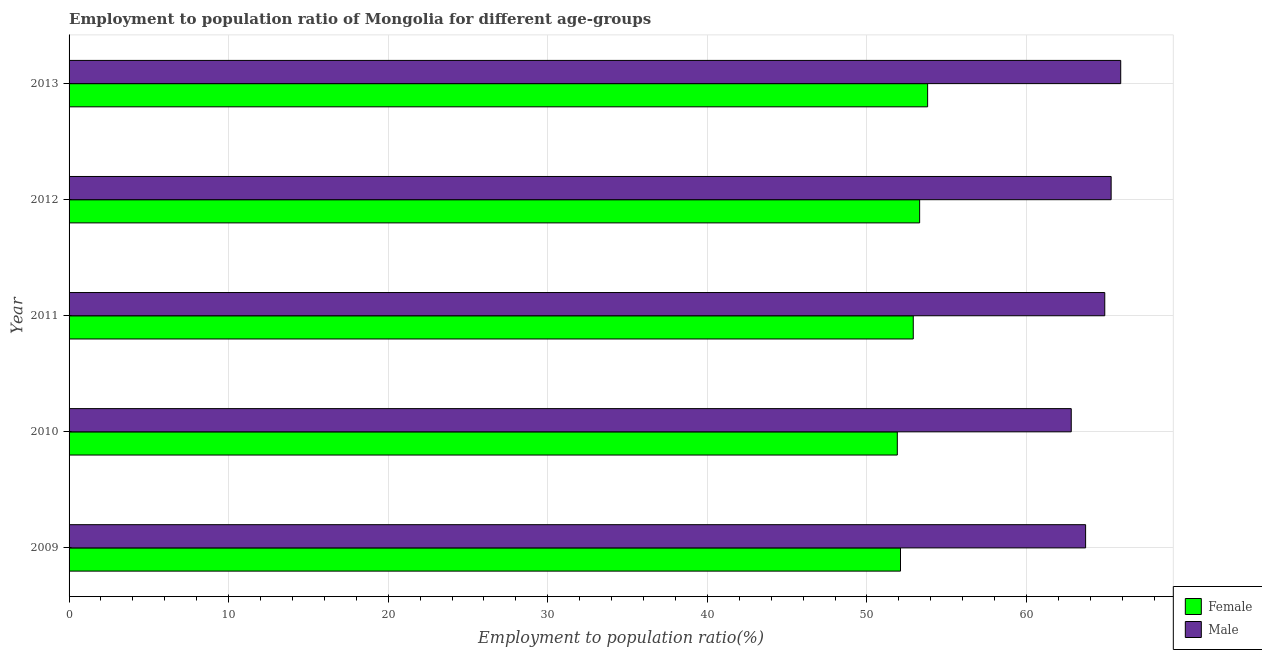Are the number of bars per tick equal to the number of legend labels?
Your answer should be compact. Yes. Are the number of bars on each tick of the Y-axis equal?
Your answer should be compact. Yes. What is the label of the 5th group of bars from the top?
Ensure brevity in your answer.  2009. In how many cases, is the number of bars for a given year not equal to the number of legend labels?
Make the answer very short. 0. What is the employment to population ratio(male) in 2011?
Keep it short and to the point. 64.9. Across all years, what is the maximum employment to population ratio(male)?
Offer a terse response. 65.9. Across all years, what is the minimum employment to population ratio(female)?
Provide a short and direct response. 51.9. What is the total employment to population ratio(male) in the graph?
Keep it short and to the point. 322.6. What is the difference between the employment to population ratio(female) in 2009 and that in 2012?
Your answer should be very brief. -1.2. What is the difference between the employment to population ratio(male) in 2010 and the employment to population ratio(female) in 2013?
Provide a succinct answer. 9. What is the average employment to population ratio(male) per year?
Offer a very short reply. 64.52. In the year 2009, what is the difference between the employment to population ratio(male) and employment to population ratio(female)?
Offer a terse response. 11.6. In how many years, is the employment to population ratio(male) greater than 36 %?
Give a very brief answer. 5. Is the difference between the employment to population ratio(male) in 2010 and 2011 greater than the difference between the employment to population ratio(female) in 2010 and 2011?
Your response must be concise. No. What is the difference between the highest and the second highest employment to population ratio(male)?
Make the answer very short. 0.6. What is the difference between the highest and the lowest employment to population ratio(female)?
Your response must be concise. 1.9. In how many years, is the employment to population ratio(male) greater than the average employment to population ratio(male) taken over all years?
Provide a short and direct response. 3. Is the sum of the employment to population ratio(male) in 2010 and 2013 greater than the maximum employment to population ratio(female) across all years?
Your answer should be very brief. Yes. What does the 1st bar from the top in 2010 represents?
Give a very brief answer. Male. What does the 2nd bar from the bottom in 2010 represents?
Your answer should be very brief. Male. How many bars are there?
Provide a short and direct response. 10. How many years are there in the graph?
Offer a terse response. 5. What is the difference between two consecutive major ticks on the X-axis?
Offer a very short reply. 10. Are the values on the major ticks of X-axis written in scientific E-notation?
Provide a short and direct response. No. Does the graph contain any zero values?
Ensure brevity in your answer.  No. Where does the legend appear in the graph?
Give a very brief answer. Bottom right. What is the title of the graph?
Offer a terse response. Employment to population ratio of Mongolia for different age-groups. What is the label or title of the X-axis?
Ensure brevity in your answer.  Employment to population ratio(%). What is the label or title of the Y-axis?
Make the answer very short. Year. What is the Employment to population ratio(%) of Female in 2009?
Offer a terse response. 52.1. What is the Employment to population ratio(%) in Male in 2009?
Offer a very short reply. 63.7. What is the Employment to population ratio(%) in Female in 2010?
Provide a succinct answer. 51.9. What is the Employment to population ratio(%) of Male in 2010?
Your answer should be very brief. 62.8. What is the Employment to population ratio(%) in Female in 2011?
Keep it short and to the point. 52.9. What is the Employment to population ratio(%) of Male in 2011?
Offer a very short reply. 64.9. What is the Employment to population ratio(%) of Female in 2012?
Give a very brief answer. 53.3. What is the Employment to population ratio(%) of Male in 2012?
Keep it short and to the point. 65.3. What is the Employment to population ratio(%) in Female in 2013?
Make the answer very short. 53.8. What is the Employment to population ratio(%) in Male in 2013?
Your answer should be compact. 65.9. Across all years, what is the maximum Employment to population ratio(%) in Female?
Make the answer very short. 53.8. Across all years, what is the maximum Employment to population ratio(%) of Male?
Your answer should be very brief. 65.9. Across all years, what is the minimum Employment to population ratio(%) in Female?
Offer a very short reply. 51.9. Across all years, what is the minimum Employment to population ratio(%) in Male?
Your answer should be compact. 62.8. What is the total Employment to population ratio(%) of Female in the graph?
Ensure brevity in your answer.  264. What is the total Employment to population ratio(%) in Male in the graph?
Offer a very short reply. 322.6. What is the difference between the Employment to population ratio(%) in Male in 2009 and that in 2010?
Keep it short and to the point. 0.9. What is the difference between the Employment to population ratio(%) in Female in 2009 and that in 2012?
Your response must be concise. -1.2. What is the difference between the Employment to population ratio(%) of Male in 2009 and that in 2012?
Provide a succinct answer. -1.6. What is the difference between the Employment to population ratio(%) in Female in 2010 and that in 2011?
Ensure brevity in your answer.  -1. What is the difference between the Employment to population ratio(%) in Male in 2010 and that in 2012?
Provide a succinct answer. -2.5. What is the difference between the Employment to population ratio(%) in Female in 2011 and that in 2012?
Your answer should be very brief. -0.4. What is the difference between the Employment to population ratio(%) of Male in 2011 and that in 2012?
Provide a succinct answer. -0.4. What is the difference between the Employment to population ratio(%) in Female in 2009 and the Employment to population ratio(%) in Male in 2012?
Your answer should be very brief. -13.2. What is the difference between the Employment to population ratio(%) of Female in 2010 and the Employment to population ratio(%) of Male in 2012?
Provide a short and direct response. -13.4. What is the difference between the Employment to population ratio(%) of Female in 2011 and the Employment to population ratio(%) of Male in 2012?
Make the answer very short. -12.4. What is the average Employment to population ratio(%) of Female per year?
Keep it short and to the point. 52.8. What is the average Employment to population ratio(%) in Male per year?
Provide a succinct answer. 64.52. In the year 2009, what is the difference between the Employment to population ratio(%) of Female and Employment to population ratio(%) of Male?
Provide a short and direct response. -11.6. In the year 2010, what is the difference between the Employment to population ratio(%) in Female and Employment to population ratio(%) in Male?
Give a very brief answer. -10.9. In the year 2011, what is the difference between the Employment to population ratio(%) of Female and Employment to population ratio(%) of Male?
Give a very brief answer. -12. In the year 2012, what is the difference between the Employment to population ratio(%) in Female and Employment to population ratio(%) in Male?
Your response must be concise. -12. In the year 2013, what is the difference between the Employment to population ratio(%) in Female and Employment to population ratio(%) in Male?
Your answer should be very brief. -12.1. What is the ratio of the Employment to population ratio(%) in Female in 2009 to that in 2010?
Your response must be concise. 1. What is the ratio of the Employment to population ratio(%) in Male in 2009 to that in 2010?
Give a very brief answer. 1.01. What is the ratio of the Employment to population ratio(%) of Female in 2009 to that in 2011?
Make the answer very short. 0.98. What is the ratio of the Employment to population ratio(%) in Male in 2009 to that in 2011?
Your response must be concise. 0.98. What is the ratio of the Employment to population ratio(%) in Female in 2009 to that in 2012?
Offer a terse response. 0.98. What is the ratio of the Employment to population ratio(%) of Male in 2009 to that in 2012?
Provide a short and direct response. 0.98. What is the ratio of the Employment to population ratio(%) in Female in 2009 to that in 2013?
Your answer should be very brief. 0.97. What is the ratio of the Employment to population ratio(%) in Male in 2009 to that in 2013?
Your answer should be compact. 0.97. What is the ratio of the Employment to population ratio(%) of Female in 2010 to that in 2011?
Give a very brief answer. 0.98. What is the ratio of the Employment to population ratio(%) in Male in 2010 to that in 2011?
Ensure brevity in your answer.  0.97. What is the ratio of the Employment to population ratio(%) of Female in 2010 to that in 2012?
Give a very brief answer. 0.97. What is the ratio of the Employment to population ratio(%) of Male in 2010 to that in 2012?
Offer a very short reply. 0.96. What is the ratio of the Employment to population ratio(%) of Female in 2010 to that in 2013?
Your response must be concise. 0.96. What is the ratio of the Employment to population ratio(%) in Male in 2010 to that in 2013?
Ensure brevity in your answer.  0.95. What is the ratio of the Employment to population ratio(%) in Female in 2011 to that in 2012?
Provide a succinct answer. 0.99. What is the ratio of the Employment to population ratio(%) of Female in 2011 to that in 2013?
Keep it short and to the point. 0.98. What is the ratio of the Employment to population ratio(%) in Male in 2011 to that in 2013?
Keep it short and to the point. 0.98. What is the ratio of the Employment to population ratio(%) of Female in 2012 to that in 2013?
Provide a short and direct response. 0.99. What is the ratio of the Employment to population ratio(%) in Male in 2012 to that in 2013?
Give a very brief answer. 0.99. What is the difference between the highest and the lowest Employment to population ratio(%) in Female?
Keep it short and to the point. 1.9. What is the difference between the highest and the lowest Employment to population ratio(%) of Male?
Your response must be concise. 3.1. 